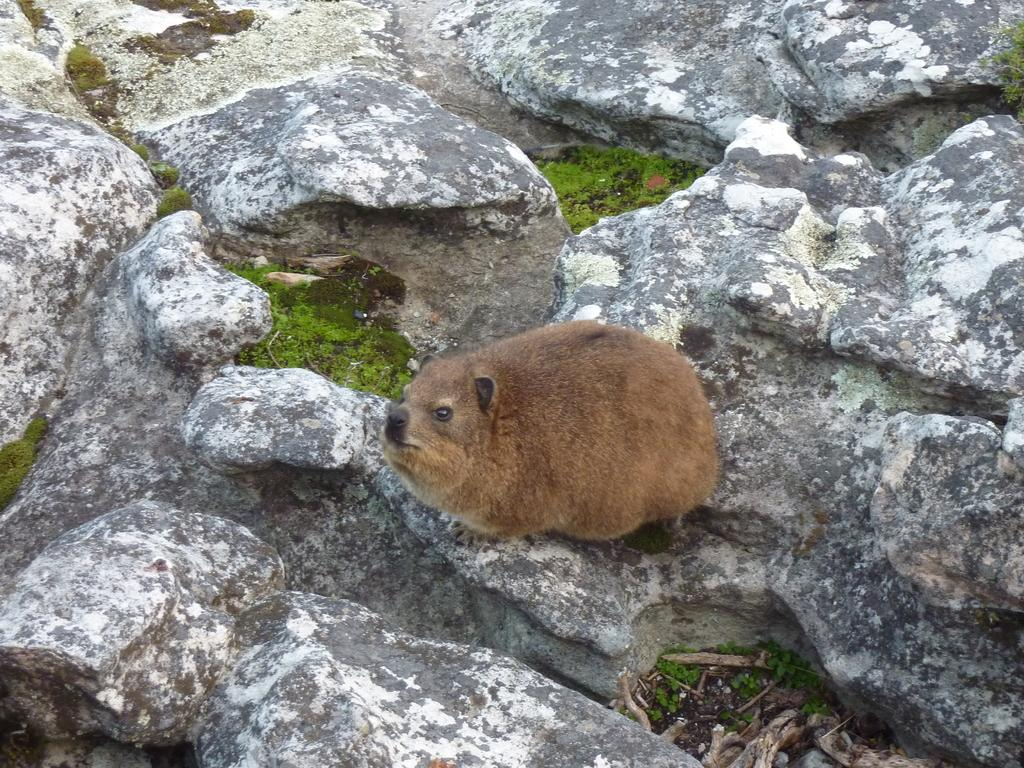What type of creature is in the image? There is an animal in the image. Where is the animal located in the image? The animal is on the ground. Can you describe the position of the animal in the image? The animal is in the center of the image. What type of grass is the animal chewing on in the image? There is no grass present in the image, and the animal is not shown chewing on anything. 